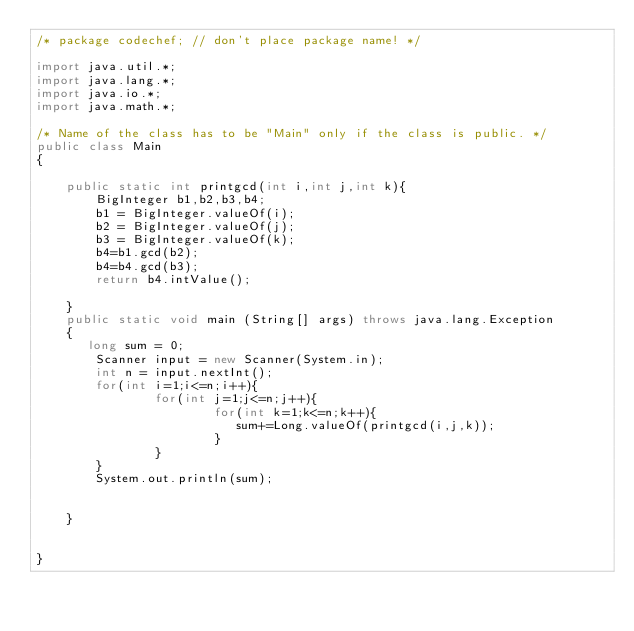Convert code to text. <code><loc_0><loc_0><loc_500><loc_500><_Java_>/* package codechef; // don't place package name! */

import java.util.*;
import java.lang.*;
import java.io.*;
import java.math.*;

/* Name of the class has to be "Main" only if the class is public. */
public class Main
{
    
    public static int printgcd(int i,int j,int k){
        BigInteger b1,b2,b3,b4;
        b1 = BigInteger.valueOf(i);
        b2 = BigInteger.valueOf(j);
        b3 = BigInteger.valueOf(k);
        b4=b1.gcd(b2);
        b4=b4.gcd(b3);
        return b4.intValue();
        
    }
	public static void main (String[] args) throws java.lang.Exception
	{
	   long sum = 0;
		Scanner input = new Scanner(System.in);
		int n = input.nextInt();
		for(int i=1;i<=n;i++){
		    	for(int j=1;j<=n;j++){
		    	    	for(int k=1;k<=n;k++){
		    	    	   sum+=Long.valueOf(printgcd(i,j,k)); 
		    	    	}
		    	}
		}
		System.out.println(sum);
		
		
	}
	
	
}
</code> 